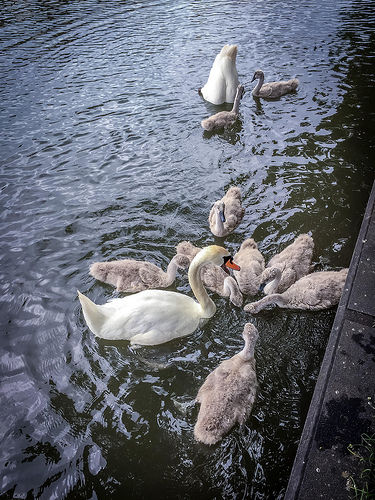<image>
Can you confirm if the swan is in the water? Yes. The swan is contained within or inside the water, showing a containment relationship. 